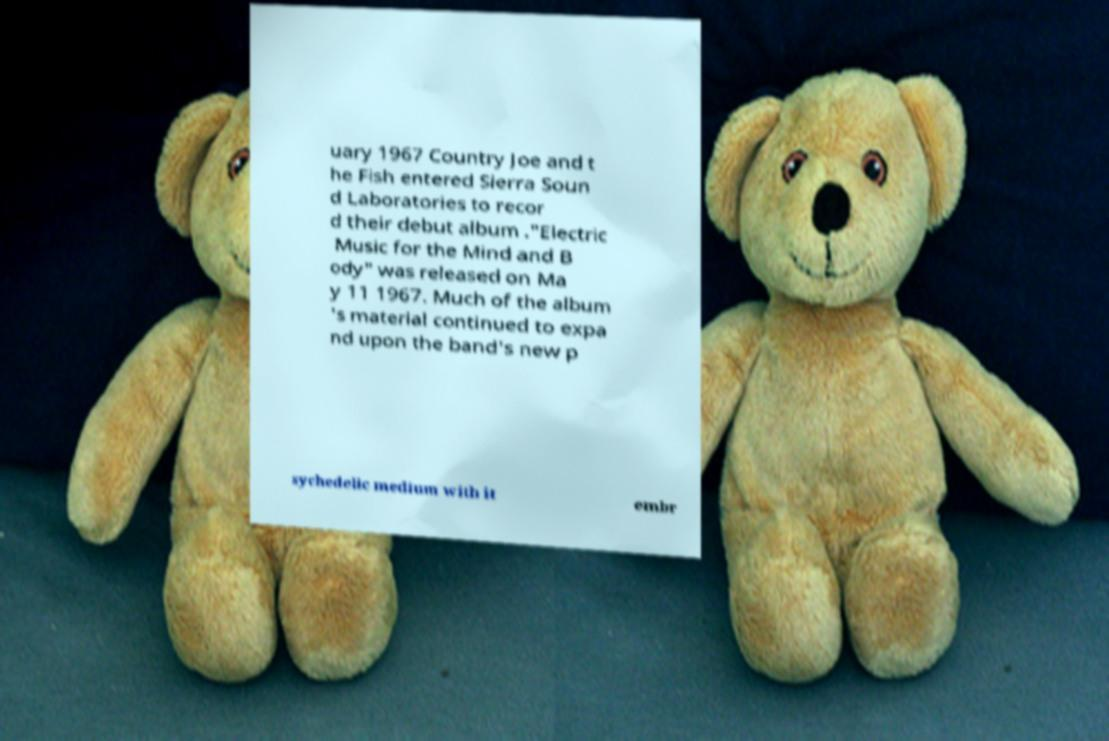I need the written content from this picture converted into text. Can you do that? uary 1967 Country Joe and t he Fish entered Sierra Soun d Laboratories to recor d their debut album ."Electric Music for the Mind and B ody" was released on Ma y 11 1967. Much of the album 's material continued to expa nd upon the band's new p sychedelic medium with it embr 